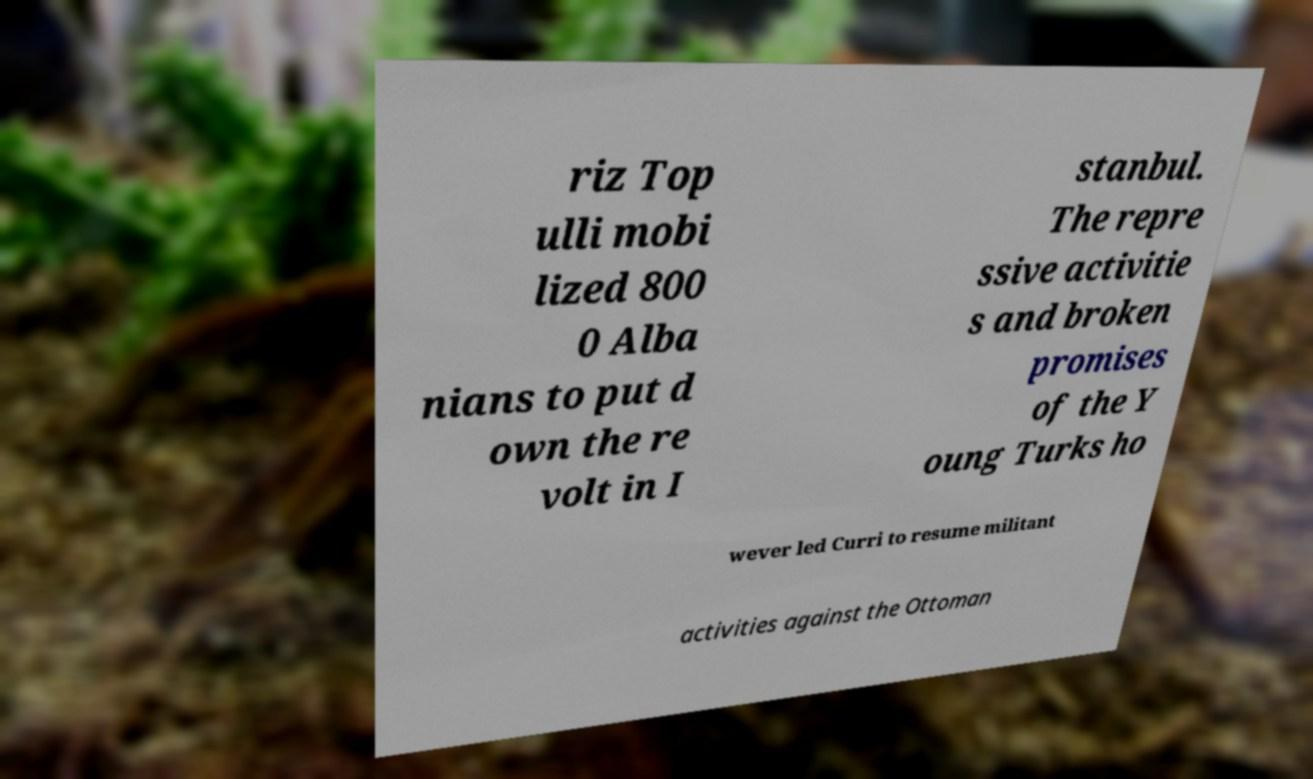Can you read and provide the text displayed in the image?This photo seems to have some interesting text. Can you extract and type it out for me? riz Top ulli mobi lized 800 0 Alba nians to put d own the re volt in I stanbul. The repre ssive activitie s and broken promises of the Y oung Turks ho wever led Curri to resume militant activities against the Ottoman 